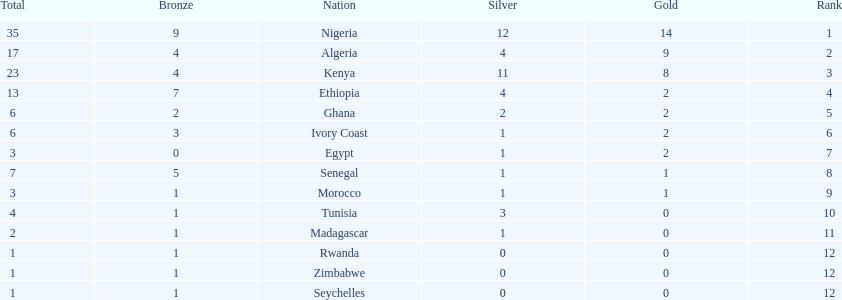What was the total number of medals the ivory coast won? 6. 